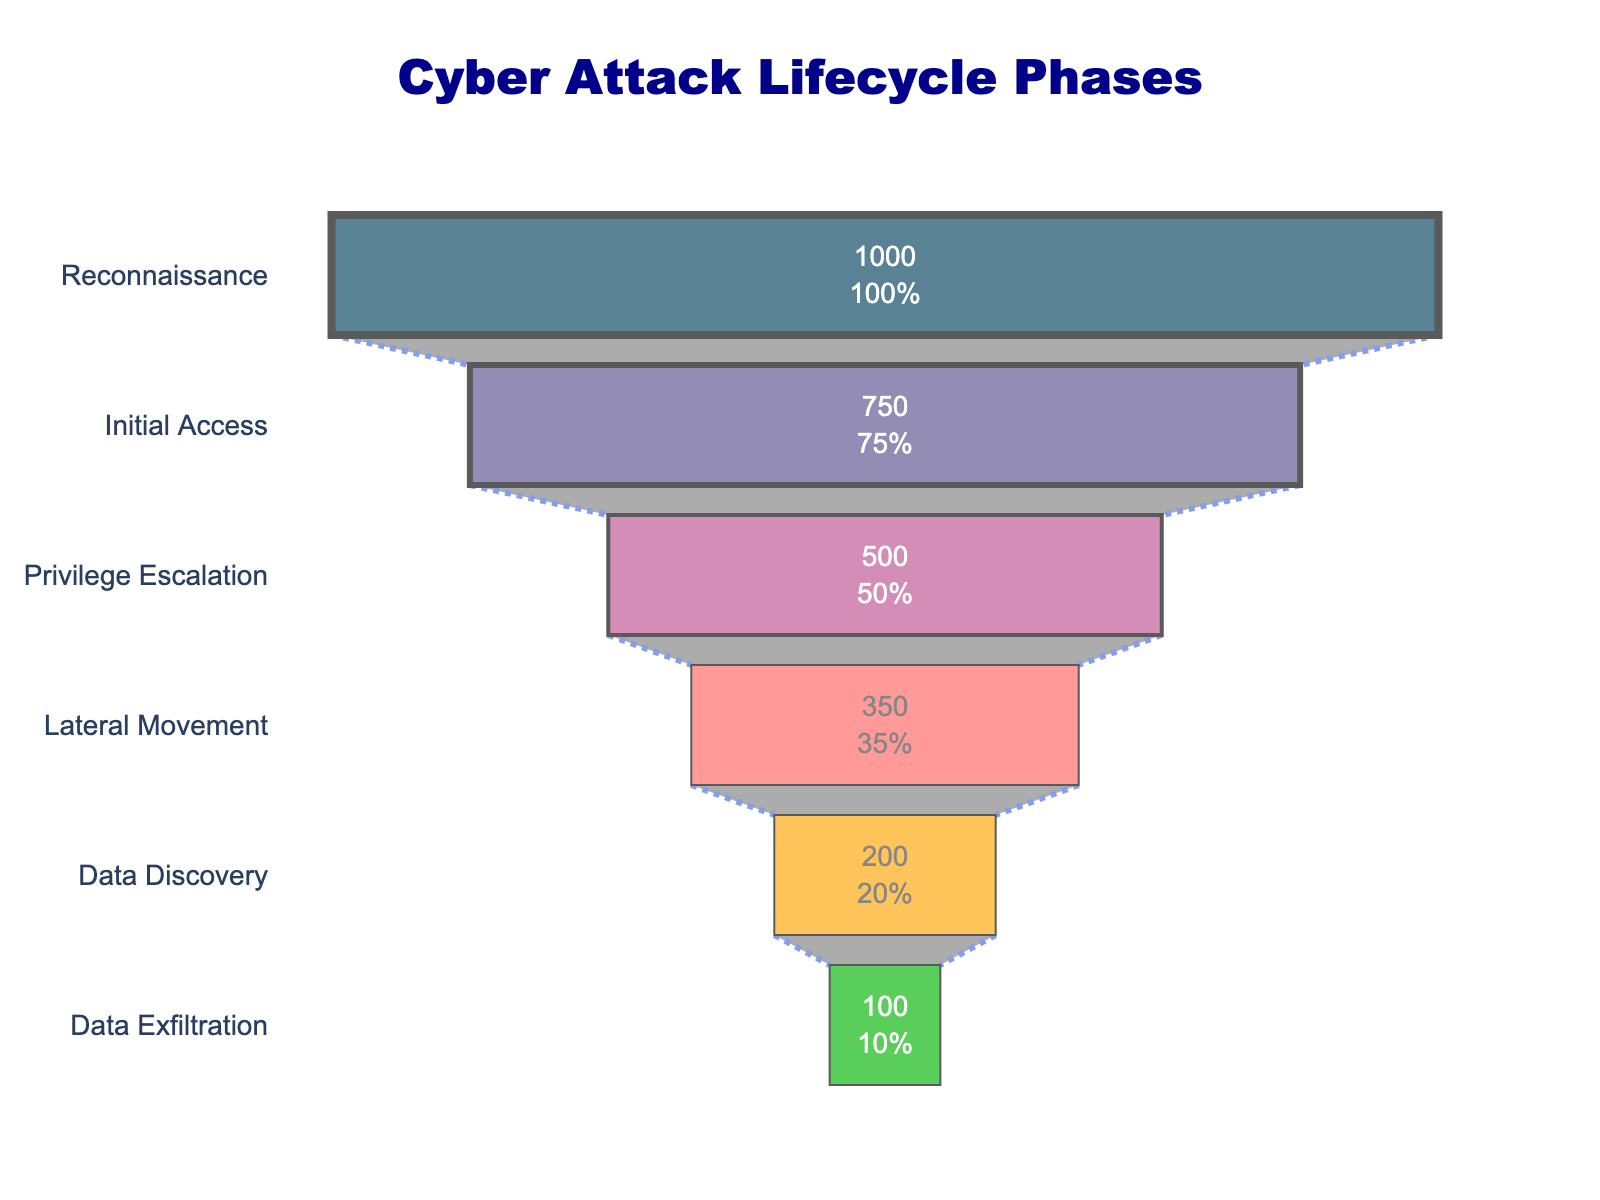What's the title of the figure? The title of the figure is typically located at the top center of the chart. Here, it clearly states "Cyber Attack Lifecycle Phases."
Answer: Cyber Attack Lifecycle Phases Which phase has the highest count? The phase with the highest count is positioned at the top of the funnel chart. In this case, it is the "Reconnaissance" phase with a count of 1000.
Answer: Reconnaissance What is the count for the Data Discovery phase? Locate the "Data Discovery" phase along the y-axis and refer to the corresponding x-axis value. The count for Data Discovery is 200.
Answer: 200 By how much does the count decrease from Initial Access to Privilege Escalation? Identify the count values for Initial Access (750) and Privilege Escalation (500). Subtract the latter from the former: 750 - 500 = 250.
Answer: 250 What percentage of the initial value does the Lateral Movement phase represent? The initial value is the count for the Reconnaissance phase, which is 1000. The count for Lateral Movement is 350. Divide 350 by 1000 and multiply by 100 to get the percentage: (350 / 1000) * 100 = 35%.
Answer: 35% Which phase has the least count? The phase with the least count is found at the narrow bottom of the funnel. In this figure, it is "Data Exfiltration" with a count of 100.
Answer: Data Exfiltration How many phases are illustrated in the figure? Count the number of distinct phases listed along the y-axis. There are six phases in this chart.
Answer: 6 What is the difference in count between the Lateral Movement and Data Exfiltration phases? Find the count values for Lateral Movement (350) and Data Exfiltration (100). Subtract the latter from the former: 350 - 100 = 250.
Answer: 250 What is the total count for all phases combined? Sum the counts of all phases: Reconnaissance (1000), Initial Access (750), Privilege Escalation (500), Lateral Movement (350), Data Discovery (200), Data Exfiltration (100). The total is 1000 + 750 + 500 + 350 + 200 + 100 = 2900.
Answer: 2900 Which phase is directly above the Data Discovery phase? Look at the funnel chart to identify the phase listed directly above "Data Discovery". It is the "Lateral Movement" phase.
Answer: Lateral Movement 